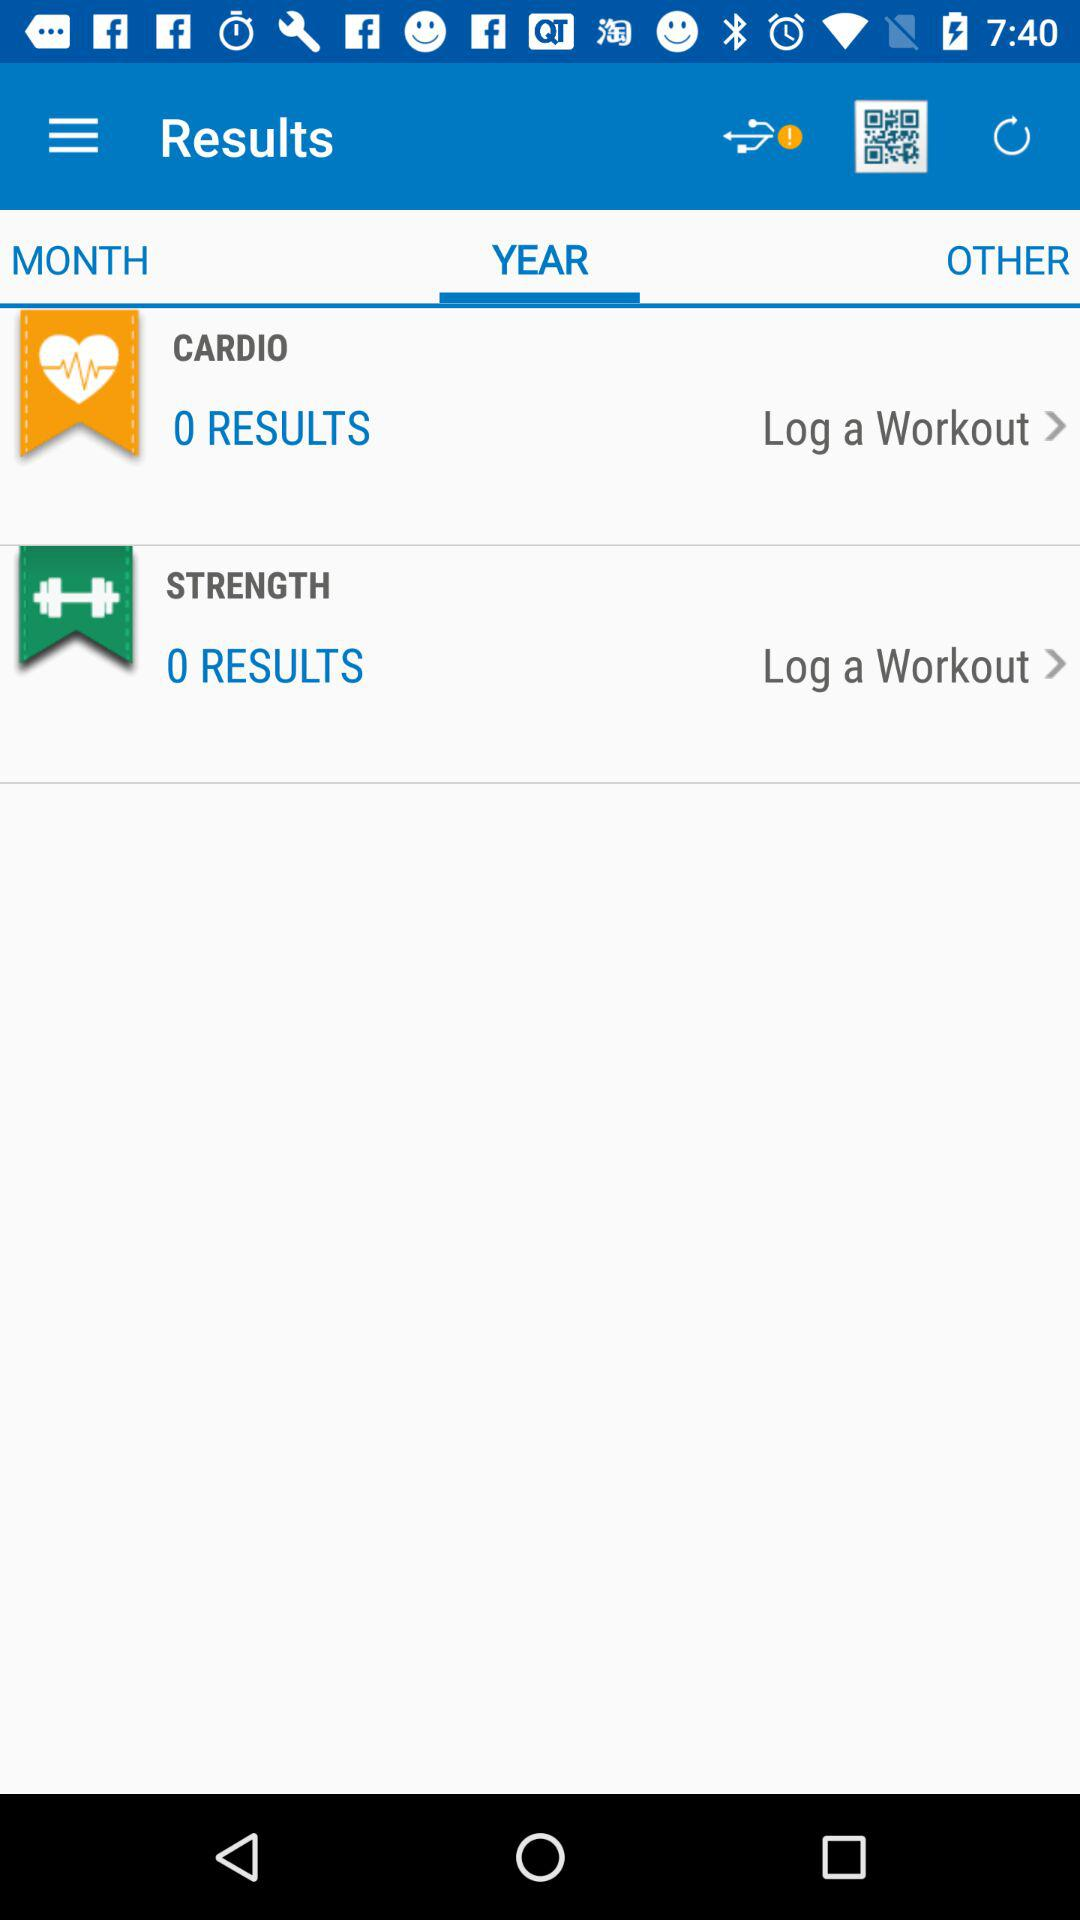How many results are there in "STRENGTH"? There are 0 results in "STRENGTH". 